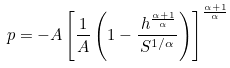<formula> <loc_0><loc_0><loc_500><loc_500>p = - A \left [ \frac { 1 } { A } \left ( 1 - \frac { \, h ^ { \frac { \alpha + 1 } { \alpha } } } { S ^ { 1 / \alpha } } \right ) \right ] ^ { \frac { \alpha + 1 } { \alpha } }</formula> 